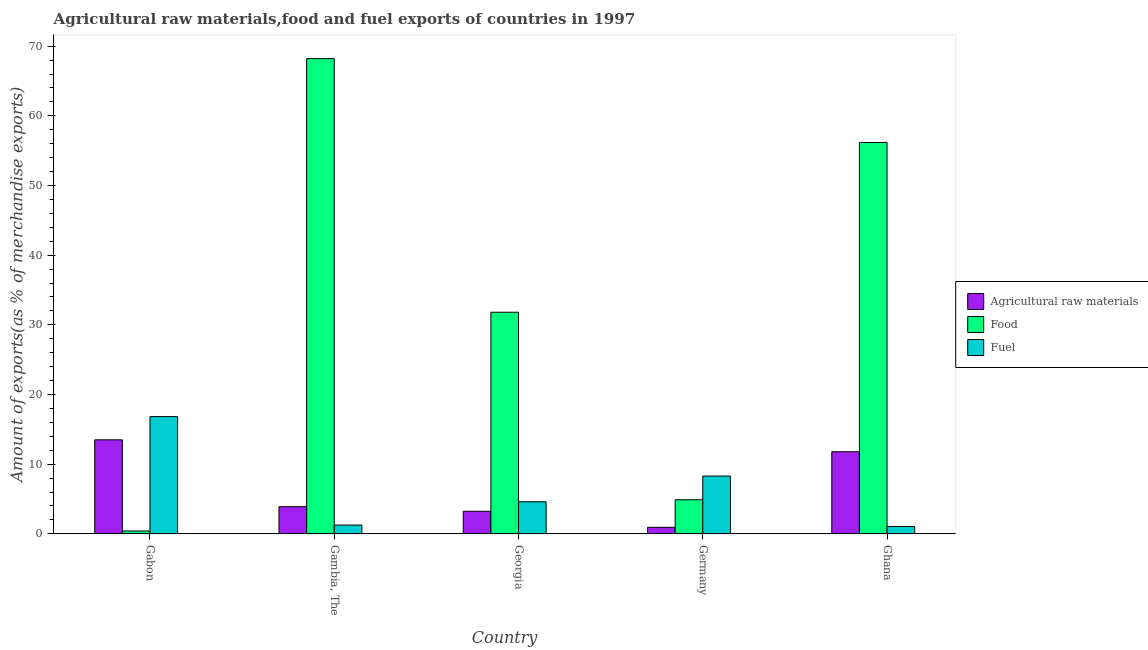How many different coloured bars are there?
Keep it short and to the point. 3. Are the number of bars on each tick of the X-axis equal?
Your response must be concise. Yes. What is the label of the 2nd group of bars from the left?
Offer a terse response. Gambia, The. In how many cases, is the number of bars for a given country not equal to the number of legend labels?
Offer a terse response. 0. What is the percentage of raw materials exports in Ghana?
Provide a succinct answer. 11.79. Across all countries, what is the maximum percentage of fuel exports?
Your answer should be very brief. 16.83. Across all countries, what is the minimum percentage of food exports?
Offer a very short reply. 0.41. In which country was the percentage of food exports maximum?
Offer a terse response. Gambia, The. In which country was the percentage of food exports minimum?
Offer a terse response. Gabon. What is the total percentage of fuel exports in the graph?
Provide a succinct answer. 32.06. What is the difference between the percentage of raw materials exports in Georgia and that in Ghana?
Your answer should be very brief. -8.54. What is the difference between the percentage of raw materials exports in Gambia, The and the percentage of food exports in Gabon?
Give a very brief answer. 3.49. What is the average percentage of raw materials exports per country?
Provide a succinct answer. 6.68. What is the difference between the percentage of fuel exports and percentage of food exports in Germany?
Your response must be concise. 3.41. What is the ratio of the percentage of food exports in Georgia to that in Germany?
Offer a very short reply. 6.5. What is the difference between the highest and the second highest percentage of food exports?
Provide a succinct answer. 12.04. What is the difference between the highest and the lowest percentage of fuel exports?
Make the answer very short. 15.77. In how many countries, is the percentage of food exports greater than the average percentage of food exports taken over all countries?
Keep it short and to the point. 2. Is the sum of the percentage of raw materials exports in Germany and Ghana greater than the maximum percentage of food exports across all countries?
Your response must be concise. No. What does the 1st bar from the left in Ghana represents?
Your response must be concise. Agricultural raw materials. What does the 3rd bar from the right in Gabon represents?
Keep it short and to the point. Agricultural raw materials. Is it the case that in every country, the sum of the percentage of raw materials exports and percentage of food exports is greater than the percentage of fuel exports?
Provide a short and direct response. No. How many bars are there?
Make the answer very short. 15. What is the difference between two consecutive major ticks on the Y-axis?
Offer a very short reply. 10. Does the graph contain grids?
Offer a very short reply. No. How many legend labels are there?
Offer a terse response. 3. How are the legend labels stacked?
Offer a very short reply. Vertical. What is the title of the graph?
Keep it short and to the point. Agricultural raw materials,food and fuel exports of countries in 1997. Does "Agriculture" appear as one of the legend labels in the graph?
Offer a very short reply. No. What is the label or title of the Y-axis?
Your answer should be very brief. Amount of exports(as % of merchandise exports). What is the Amount of exports(as % of merchandise exports) of Agricultural raw materials in Gabon?
Make the answer very short. 13.5. What is the Amount of exports(as % of merchandise exports) of Food in Gabon?
Give a very brief answer. 0.41. What is the Amount of exports(as % of merchandise exports) in Fuel in Gabon?
Offer a very short reply. 16.83. What is the Amount of exports(as % of merchandise exports) in Agricultural raw materials in Gambia, The?
Ensure brevity in your answer.  3.9. What is the Amount of exports(as % of merchandise exports) in Food in Gambia, The?
Offer a very short reply. 68.21. What is the Amount of exports(as % of merchandise exports) of Fuel in Gambia, The?
Your answer should be compact. 1.26. What is the Amount of exports(as % of merchandise exports) in Agricultural raw materials in Georgia?
Provide a short and direct response. 3.25. What is the Amount of exports(as % of merchandise exports) of Food in Georgia?
Give a very brief answer. 31.81. What is the Amount of exports(as % of merchandise exports) in Fuel in Georgia?
Keep it short and to the point. 4.6. What is the Amount of exports(as % of merchandise exports) in Agricultural raw materials in Germany?
Your response must be concise. 0.94. What is the Amount of exports(as % of merchandise exports) of Food in Germany?
Your answer should be very brief. 4.89. What is the Amount of exports(as % of merchandise exports) of Fuel in Germany?
Keep it short and to the point. 8.3. What is the Amount of exports(as % of merchandise exports) of Agricultural raw materials in Ghana?
Provide a succinct answer. 11.79. What is the Amount of exports(as % of merchandise exports) of Food in Ghana?
Your answer should be very brief. 56.17. What is the Amount of exports(as % of merchandise exports) in Fuel in Ghana?
Keep it short and to the point. 1.06. Across all countries, what is the maximum Amount of exports(as % of merchandise exports) of Agricultural raw materials?
Your answer should be very brief. 13.5. Across all countries, what is the maximum Amount of exports(as % of merchandise exports) of Food?
Give a very brief answer. 68.21. Across all countries, what is the maximum Amount of exports(as % of merchandise exports) of Fuel?
Provide a succinct answer. 16.83. Across all countries, what is the minimum Amount of exports(as % of merchandise exports) in Agricultural raw materials?
Keep it short and to the point. 0.94. Across all countries, what is the minimum Amount of exports(as % of merchandise exports) of Food?
Ensure brevity in your answer.  0.41. Across all countries, what is the minimum Amount of exports(as % of merchandise exports) of Fuel?
Provide a short and direct response. 1.06. What is the total Amount of exports(as % of merchandise exports) of Agricultural raw materials in the graph?
Your answer should be compact. 33.38. What is the total Amount of exports(as % of merchandise exports) of Food in the graph?
Your answer should be very brief. 161.49. What is the total Amount of exports(as % of merchandise exports) of Fuel in the graph?
Keep it short and to the point. 32.06. What is the difference between the Amount of exports(as % of merchandise exports) in Agricultural raw materials in Gabon and that in Gambia, The?
Provide a succinct answer. 9.59. What is the difference between the Amount of exports(as % of merchandise exports) of Food in Gabon and that in Gambia, The?
Offer a terse response. -67.8. What is the difference between the Amount of exports(as % of merchandise exports) in Fuel in Gabon and that in Gambia, The?
Your response must be concise. 15.57. What is the difference between the Amount of exports(as % of merchandise exports) in Agricultural raw materials in Gabon and that in Georgia?
Offer a terse response. 10.25. What is the difference between the Amount of exports(as % of merchandise exports) of Food in Gabon and that in Georgia?
Your answer should be compact. -31.4. What is the difference between the Amount of exports(as % of merchandise exports) of Fuel in Gabon and that in Georgia?
Your response must be concise. 12.22. What is the difference between the Amount of exports(as % of merchandise exports) of Agricultural raw materials in Gabon and that in Germany?
Provide a succinct answer. 12.55. What is the difference between the Amount of exports(as % of merchandise exports) of Food in Gabon and that in Germany?
Ensure brevity in your answer.  -4.48. What is the difference between the Amount of exports(as % of merchandise exports) in Fuel in Gabon and that in Germany?
Offer a terse response. 8.53. What is the difference between the Amount of exports(as % of merchandise exports) in Agricultural raw materials in Gabon and that in Ghana?
Keep it short and to the point. 1.71. What is the difference between the Amount of exports(as % of merchandise exports) in Food in Gabon and that in Ghana?
Your response must be concise. -55.76. What is the difference between the Amount of exports(as % of merchandise exports) of Fuel in Gabon and that in Ghana?
Make the answer very short. 15.77. What is the difference between the Amount of exports(as % of merchandise exports) in Agricultural raw materials in Gambia, The and that in Georgia?
Provide a succinct answer. 0.66. What is the difference between the Amount of exports(as % of merchandise exports) of Food in Gambia, The and that in Georgia?
Provide a succinct answer. 36.4. What is the difference between the Amount of exports(as % of merchandise exports) in Fuel in Gambia, The and that in Georgia?
Offer a terse response. -3.34. What is the difference between the Amount of exports(as % of merchandise exports) in Agricultural raw materials in Gambia, The and that in Germany?
Your answer should be very brief. 2.96. What is the difference between the Amount of exports(as % of merchandise exports) of Food in Gambia, The and that in Germany?
Your answer should be very brief. 63.31. What is the difference between the Amount of exports(as % of merchandise exports) in Fuel in Gambia, The and that in Germany?
Your answer should be compact. -7.04. What is the difference between the Amount of exports(as % of merchandise exports) of Agricultural raw materials in Gambia, The and that in Ghana?
Ensure brevity in your answer.  -7.89. What is the difference between the Amount of exports(as % of merchandise exports) of Food in Gambia, The and that in Ghana?
Give a very brief answer. 12.04. What is the difference between the Amount of exports(as % of merchandise exports) in Fuel in Gambia, The and that in Ghana?
Ensure brevity in your answer.  0.2. What is the difference between the Amount of exports(as % of merchandise exports) of Agricultural raw materials in Georgia and that in Germany?
Offer a very short reply. 2.3. What is the difference between the Amount of exports(as % of merchandise exports) in Food in Georgia and that in Germany?
Your answer should be compact. 26.92. What is the difference between the Amount of exports(as % of merchandise exports) of Fuel in Georgia and that in Germany?
Give a very brief answer. -3.69. What is the difference between the Amount of exports(as % of merchandise exports) of Agricultural raw materials in Georgia and that in Ghana?
Provide a succinct answer. -8.54. What is the difference between the Amount of exports(as % of merchandise exports) of Food in Georgia and that in Ghana?
Make the answer very short. -24.36. What is the difference between the Amount of exports(as % of merchandise exports) of Fuel in Georgia and that in Ghana?
Ensure brevity in your answer.  3.54. What is the difference between the Amount of exports(as % of merchandise exports) of Agricultural raw materials in Germany and that in Ghana?
Ensure brevity in your answer.  -10.84. What is the difference between the Amount of exports(as % of merchandise exports) of Food in Germany and that in Ghana?
Your response must be concise. -51.28. What is the difference between the Amount of exports(as % of merchandise exports) of Fuel in Germany and that in Ghana?
Keep it short and to the point. 7.24. What is the difference between the Amount of exports(as % of merchandise exports) of Agricultural raw materials in Gabon and the Amount of exports(as % of merchandise exports) of Food in Gambia, The?
Give a very brief answer. -54.71. What is the difference between the Amount of exports(as % of merchandise exports) of Agricultural raw materials in Gabon and the Amount of exports(as % of merchandise exports) of Fuel in Gambia, The?
Provide a short and direct response. 12.24. What is the difference between the Amount of exports(as % of merchandise exports) of Food in Gabon and the Amount of exports(as % of merchandise exports) of Fuel in Gambia, The?
Your response must be concise. -0.85. What is the difference between the Amount of exports(as % of merchandise exports) in Agricultural raw materials in Gabon and the Amount of exports(as % of merchandise exports) in Food in Georgia?
Provide a succinct answer. -18.31. What is the difference between the Amount of exports(as % of merchandise exports) of Agricultural raw materials in Gabon and the Amount of exports(as % of merchandise exports) of Fuel in Georgia?
Provide a short and direct response. 8.89. What is the difference between the Amount of exports(as % of merchandise exports) in Food in Gabon and the Amount of exports(as % of merchandise exports) in Fuel in Georgia?
Your response must be concise. -4.19. What is the difference between the Amount of exports(as % of merchandise exports) in Agricultural raw materials in Gabon and the Amount of exports(as % of merchandise exports) in Food in Germany?
Give a very brief answer. 8.6. What is the difference between the Amount of exports(as % of merchandise exports) of Agricultural raw materials in Gabon and the Amount of exports(as % of merchandise exports) of Fuel in Germany?
Offer a terse response. 5.2. What is the difference between the Amount of exports(as % of merchandise exports) in Food in Gabon and the Amount of exports(as % of merchandise exports) in Fuel in Germany?
Ensure brevity in your answer.  -7.89. What is the difference between the Amount of exports(as % of merchandise exports) of Agricultural raw materials in Gabon and the Amount of exports(as % of merchandise exports) of Food in Ghana?
Keep it short and to the point. -42.67. What is the difference between the Amount of exports(as % of merchandise exports) of Agricultural raw materials in Gabon and the Amount of exports(as % of merchandise exports) of Fuel in Ghana?
Your response must be concise. 12.43. What is the difference between the Amount of exports(as % of merchandise exports) in Food in Gabon and the Amount of exports(as % of merchandise exports) in Fuel in Ghana?
Your answer should be very brief. -0.65. What is the difference between the Amount of exports(as % of merchandise exports) in Agricultural raw materials in Gambia, The and the Amount of exports(as % of merchandise exports) in Food in Georgia?
Your answer should be compact. -27.91. What is the difference between the Amount of exports(as % of merchandise exports) in Agricultural raw materials in Gambia, The and the Amount of exports(as % of merchandise exports) in Fuel in Georgia?
Offer a terse response. -0.7. What is the difference between the Amount of exports(as % of merchandise exports) in Food in Gambia, The and the Amount of exports(as % of merchandise exports) in Fuel in Georgia?
Your answer should be compact. 63.6. What is the difference between the Amount of exports(as % of merchandise exports) of Agricultural raw materials in Gambia, The and the Amount of exports(as % of merchandise exports) of Food in Germany?
Provide a short and direct response. -0.99. What is the difference between the Amount of exports(as % of merchandise exports) of Agricultural raw materials in Gambia, The and the Amount of exports(as % of merchandise exports) of Fuel in Germany?
Keep it short and to the point. -4.4. What is the difference between the Amount of exports(as % of merchandise exports) in Food in Gambia, The and the Amount of exports(as % of merchandise exports) in Fuel in Germany?
Your response must be concise. 59.91. What is the difference between the Amount of exports(as % of merchandise exports) in Agricultural raw materials in Gambia, The and the Amount of exports(as % of merchandise exports) in Food in Ghana?
Your response must be concise. -52.27. What is the difference between the Amount of exports(as % of merchandise exports) in Agricultural raw materials in Gambia, The and the Amount of exports(as % of merchandise exports) in Fuel in Ghana?
Offer a terse response. 2.84. What is the difference between the Amount of exports(as % of merchandise exports) of Food in Gambia, The and the Amount of exports(as % of merchandise exports) of Fuel in Ghana?
Provide a short and direct response. 67.15. What is the difference between the Amount of exports(as % of merchandise exports) in Agricultural raw materials in Georgia and the Amount of exports(as % of merchandise exports) in Food in Germany?
Your response must be concise. -1.65. What is the difference between the Amount of exports(as % of merchandise exports) of Agricultural raw materials in Georgia and the Amount of exports(as % of merchandise exports) of Fuel in Germany?
Provide a succinct answer. -5.05. What is the difference between the Amount of exports(as % of merchandise exports) of Food in Georgia and the Amount of exports(as % of merchandise exports) of Fuel in Germany?
Your answer should be very brief. 23.51. What is the difference between the Amount of exports(as % of merchandise exports) in Agricultural raw materials in Georgia and the Amount of exports(as % of merchandise exports) in Food in Ghana?
Offer a terse response. -52.92. What is the difference between the Amount of exports(as % of merchandise exports) of Agricultural raw materials in Georgia and the Amount of exports(as % of merchandise exports) of Fuel in Ghana?
Offer a very short reply. 2.18. What is the difference between the Amount of exports(as % of merchandise exports) in Food in Georgia and the Amount of exports(as % of merchandise exports) in Fuel in Ghana?
Make the answer very short. 30.75. What is the difference between the Amount of exports(as % of merchandise exports) in Agricultural raw materials in Germany and the Amount of exports(as % of merchandise exports) in Food in Ghana?
Provide a succinct answer. -55.23. What is the difference between the Amount of exports(as % of merchandise exports) in Agricultural raw materials in Germany and the Amount of exports(as % of merchandise exports) in Fuel in Ghana?
Give a very brief answer. -0.12. What is the difference between the Amount of exports(as % of merchandise exports) of Food in Germany and the Amount of exports(as % of merchandise exports) of Fuel in Ghana?
Your answer should be compact. 3.83. What is the average Amount of exports(as % of merchandise exports) of Agricultural raw materials per country?
Provide a short and direct response. 6.68. What is the average Amount of exports(as % of merchandise exports) of Food per country?
Ensure brevity in your answer.  32.3. What is the average Amount of exports(as % of merchandise exports) in Fuel per country?
Keep it short and to the point. 6.41. What is the difference between the Amount of exports(as % of merchandise exports) of Agricultural raw materials and Amount of exports(as % of merchandise exports) of Food in Gabon?
Ensure brevity in your answer.  13.09. What is the difference between the Amount of exports(as % of merchandise exports) of Agricultural raw materials and Amount of exports(as % of merchandise exports) of Fuel in Gabon?
Ensure brevity in your answer.  -3.33. What is the difference between the Amount of exports(as % of merchandise exports) of Food and Amount of exports(as % of merchandise exports) of Fuel in Gabon?
Provide a short and direct response. -16.42. What is the difference between the Amount of exports(as % of merchandise exports) in Agricultural raw materials and Amount of exports(as % of merchandise exports) in Food in Gambia, The?
Offer a very short reply. -64.31. What is the difference between the Amount of exports(as % of merchandise exports) in Agricultural raw materials and Amount of exports(as % of merchandise exports) in Fuel in Gambia, The?
Ensure brevity in your answer.  2.64. What is the difference between the Amount of exports(as % of merchandise exports) of Food and Amount of exports(as % of merchandise exports) of Fuel in Gambia, The?
Keep it short and to the point. 66.95. What is the difference between the Amount of exports(as % of merchandise exports) in Agricultural raw materials and Amount of exports(as % of merchandise exports) in Food in Georgia?
Provide a short and direct response. -28.56. What is the difference between the Amount of exports(as % of merchandise exports) of Agricultural raw materials and Amount of exports(as % of merchandise exports) of Fuel in Georgia?
Provide a short and direct response. -1.36. What is the difference between the Amount of exports(as % of merchandise exports) in Food and Amount of exports(as % of merchandise exports) in Fuel in Georgia?
Your response must be concise. 27.2. What is the difference between the Amount of exports(as % of merchandise exports) in Agricultural raw materials and Amount of exports(as % of merchandise exports) in Food in Germany?
Give a very brief answer. -3.95. What is the difference between the Amount of exports(as % of merchandise exports) in Agricultural raw materials and Amount of exports(as % of merchandise exports) in Fuel in Germany?
Provide a succinct answer. -7.35. What is the difference between the Amount of exports(as % of merchandise exports) in Food and Amount of exports(as % of merchandise exports) in Fuel in Germany?
Offer a very short reply. -3.41. What is the difference between the Amount of exports(as % of merchandise exports) in Agricultural raw materials and Amount of exports(as % of merchandise exports) in Food in Ghana?
Your answer should be compact. -44.38. What is the difference between the Amount of exports(as % of merchandise exports) of Agricultural raw materials and Amount of exports(as % of merchandise exports) of Fuel in Ghana?
Your response must be concise. 10.73. What is the difference between the Amount of exports(as % of merchandise exports) of Food and Amount of exports(as % of merchandise exports) of Fuel in Ghana?
Provide a short and direct response. 55.11. What is the ratio of the Amount of exports(as % of merchandise exports) in Agricultural raw materials in Gabon to that in Gambia, The?
Keep it short and to the point. 3.46. What is the ratio of the Amount of exports(as % of merchandise exports) of Food in Gabon to that in Gambia, The?
Provide a succinct answer. 0.01. What is the ratio of the Amount of exports(as % of merchandise exports) in Fuel in Gabon to that in Gambia, The?
Your response must be concise. 13.34. What is the ratio of the Amount of exports(as % of merchandise exports) of Agricultural raw materials in Gabon to that in Georgia?
Your response must be concise. 4.16. What is the ratio of the Amount of exports(as % of merchandise exports) in Food in Gabon to that in Georgia?
Keep it short and to the point. 0.01. What is the ratio of the Amount of exports(as % of merchandise exports) in Fuel in Gabon to that in Georgia?
Your answer should be compact. 3.65. What is the ratio of the Amount of exports(as % of merchandise exports) in Agricultural raw materials in Gabon to that in Germany?
Provide a short and direct response. 14.29. What is the ratio of the Amount of exports(as % of merchandise exports) of Food in Gabon to that in Germany?
Keep it short and to the point. 0.08. What is the ratio of the Amount of exports(as % of merchandise exports) of Fuel in Gabon to that in Germany?
Provide a succinct answer. 2.03. What is the ratio of the Amount of exports(as % of merchandise exports) in Agricultural raw materials in Gabon to that in Ghana?
Provide a short and direct response. 1.15. What is the ratio of the Amount of exports(as % of merchandise exports) in Food in Gabon to that in Ghana?
Make the answer very short. 0.01. What is the ratio of the Amount of exports(as % of merchandise exports) in Fuel in Gabon to that in Ghana?
Make the answer very short. 15.83. What is the ratio of the Amount of exports(as % of merchandise exports) of Agricultural raw materials in Gambia, The to that in Georgia?
Offer a terse response. 1.2. What is the ratio of the Amount of exports(as % of merchandise exports) of Food in Gambia, The to that in Georgia?
Keep it short and to the point. 2.14. What is the ratio of the Amount of exports(as % of merchandise exports) in Fuel in Gambia, The to that in Georgia?
Give a very brief answer. 0.27. What is the ratio of the Amount of exports(as % of merchandise exports) of Agricultural raw materials in Gambia, The to that in Germany?
Make the answer very short. 4.13. What is the ratio of the Amount of exports(as % of merchandise exports) in Food in Gambia, The to that in Germany?
Keep it short and to the point. 13.94. What is the ratio of the Amount of exports(as % of merchandise exports) in Fuel in Gambia, The to that in Germany?
Your response must be concise. 0.15. What is the ratio of the Amount of exports(as % of merchandise exports) in Agricultural raw materials in Gambia, The to that in Ghana?
Give a very brief answer. 0.33. What is the ratio of the Amount of exports(as % of merchandise exports) of Food in Gambia, The to that in Ghana?
Ensure brevity in your answer.  1.21. What is the ratio of the Amount of exports(as % of merchandise exports) in Fuel in Gambia, The to that in Ghana?
Keep it short and to the point. 1.19. What is the ratio of the Amount of exports(as % of merchandise exports) of Agricultural raw materials in Georgia to that in Germany?
Your answer should be very brief. 3.44. What is the ratio of the Amount of exports(as % of merchandise exports) in Food in Georgia to that in Germany?
Offer a terse response. 6.5. What is the ratio of the Amount of exports(as % of merchandise exports) of Fuel in Georgia to that in Germany?
Make the answer very short. 0.55. What is the ratio of the Amount of exports(as % of merchandise exports) of Agricultural raw materials in Georgia to that in Ghana?
Your answer should be compact. 0.28. What is the ratio of the Amount of exports(as % of merchandise exports) in Food in Georgia to that in Ghana?
Keep it short and to the point. 0.57. What is the ratio of the Amount of exports(as % of merchandise exports) of Fuel in Georgia to that in Ghana?
Offer a very short reply. 4.33. What is the ratio of the Amount of exports(as % of merchandise exports) in Agricultural raw materials in Germany to that in Ghana?
Your answer should be very brief. 0.08. What is the ratio of the Amount of exports(as % of merchandise exports) in Food in Germany to that in Ghana?
Make the answer very short. 0.09. What is the ratio of the Amount of exports(as % of merchandise exports) in Fuel in Germany to that in Ghana?
Give a very brief answer. 7.81. What is the difference between the highest and the second highest Amount of exports(as % of merchandise exports) in Agricultural raw materials?
Offer a very short reply. 1.71. What is the difference between the highest and the second highest Amount of exports(as % of merchandise exports) in Food?
Your answer should be compact. 12.04. What is the difference between the highest and the second highest Amount of exports(as % of merchandise exports) of Fuel?
Offer a very short reply. 8.53. What is the difference between the highest and the lowest Amount of exports(as % of merchandise exports) of Agricultural raw materials?
Make the answer very short. 12.55. What is the difference between the highest and the lowest Amount of exports(as % of merchandise exports) in Food?
Offer a terse response. 67.8. What is the difference between the highest and the lowest Amount of exports(as % of merchandise exports) in Fuel?
Provide a succinct answer. 15.77. 